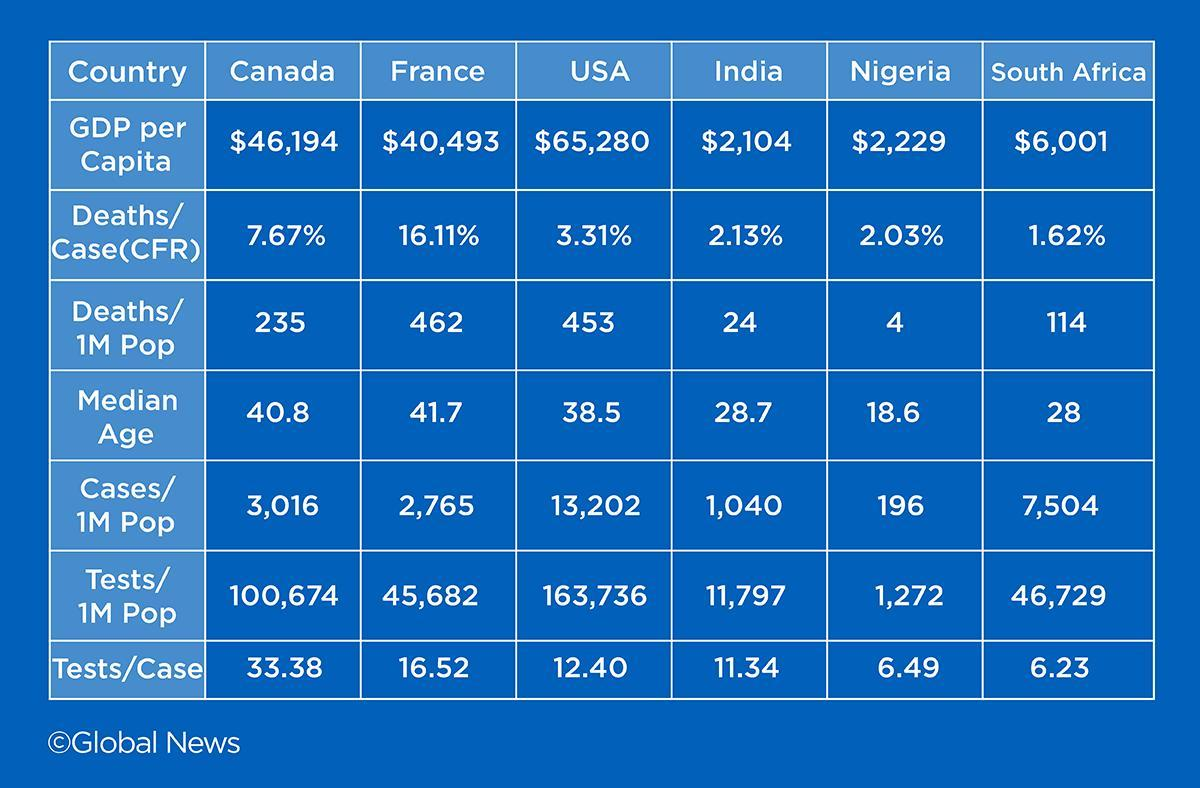Which country has the lowest GDP per Capita?
Answer the question with a short phrase. India Which country has reported least number of deaths per one million population? Nigeria What is the median age of the population in India? 28.7 Which country has the second highest GDP per Capita as per the given data? Canada What is the number of cases per one million population in France? 2,765 How many tests per cases were done in India? 11.34 Which country has reported the highest number of cases per one million population? USA What is the median age of the population in USA? 38.5 Which country has the highest GDP per Capita as per the given data? USA Which country has done the least number of tests per case? South Africa 